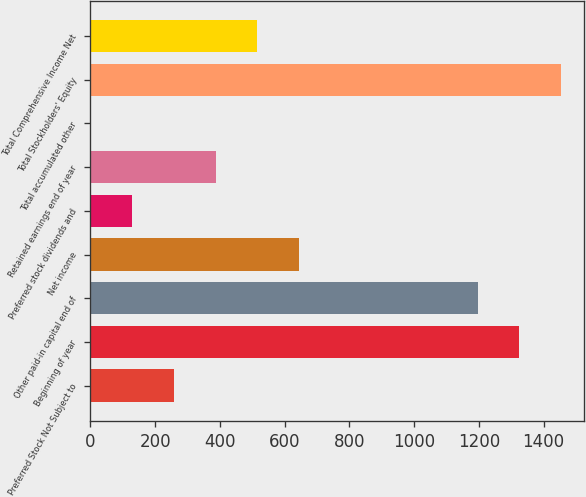<chart> <loc_0><loc_0><loc_500><loc_500><bar_chart><fcel>Preferred Stock Not Subject to<fcel>Beginning of year<fcel>Other paid-in capital end of<fcel>Net income<fcel>Preferred stock dividends and<fcel>Retained earnings end of year<fcel>Total accumulated other<fcel>Total Stockholders' Equity<fcel>Total Comprehensive Income Net<nl><fcel>258.2<fcel>1324.6<fcel>1196<fcel>644<fcel>129.6<fcel>386.8<fcel>1<fcel>1453.2<fcel>515.4<nl></chart> 